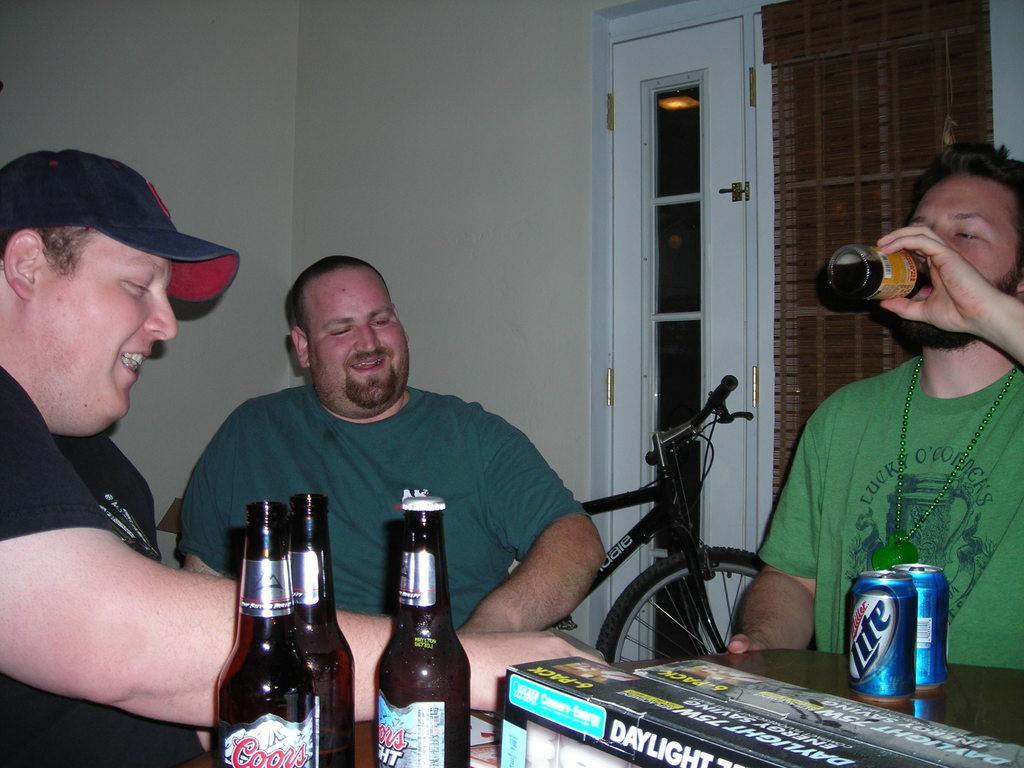Can you describe this image briefly? It is a room there are three people , there are some alcohol bottles on the table in front of them and some other things, coke tins one person is drinking the bottle other two persons are laughing, behind them there is a bicycle in the background there is a window and a wall. 